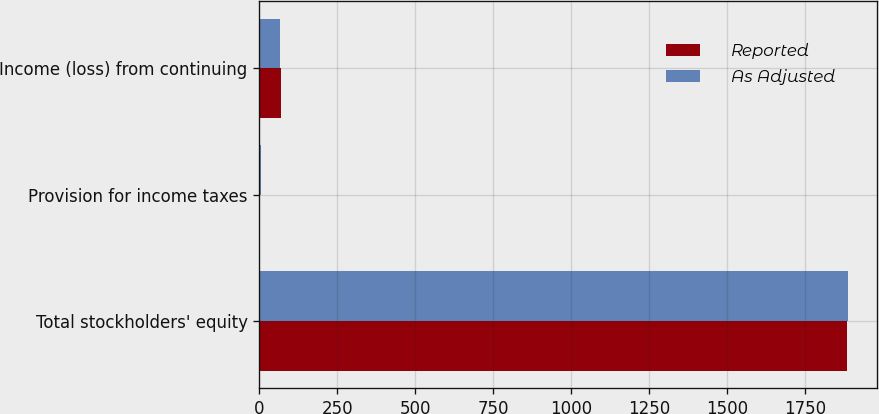Convert chart to OTSL. <chart><loc_0><loc_0><loc_500><loc_500><stacked_bar_chart><ecel><fcel>Total stockholders' equity<fcel>Provision for income taxes<fcel>Income (loss) from continuing<nl><fcel>Reported<fcel>1883.5<fcel>1.8<fcel>68.9<nl><fcel>As Adjusted<fcel>1886.7<fcel>5<fcel>65.7<nl></chart> 